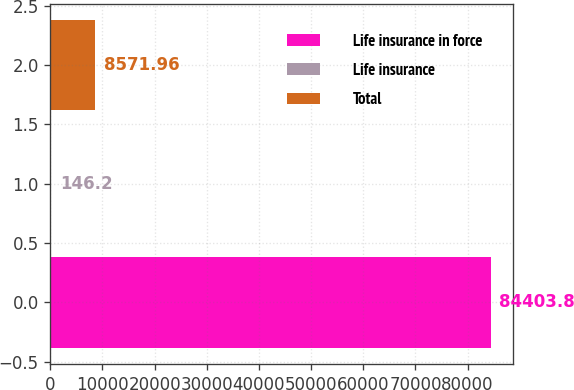<chart> <loc_0><loc_0><loc_500><loc_500><bar_chart><fcel>Life insurance in force<fcel>Life insurance<fcel>Total<nl><fcel>84403.8<fcel>146.2<fcel>8571.96<nl></chart> 